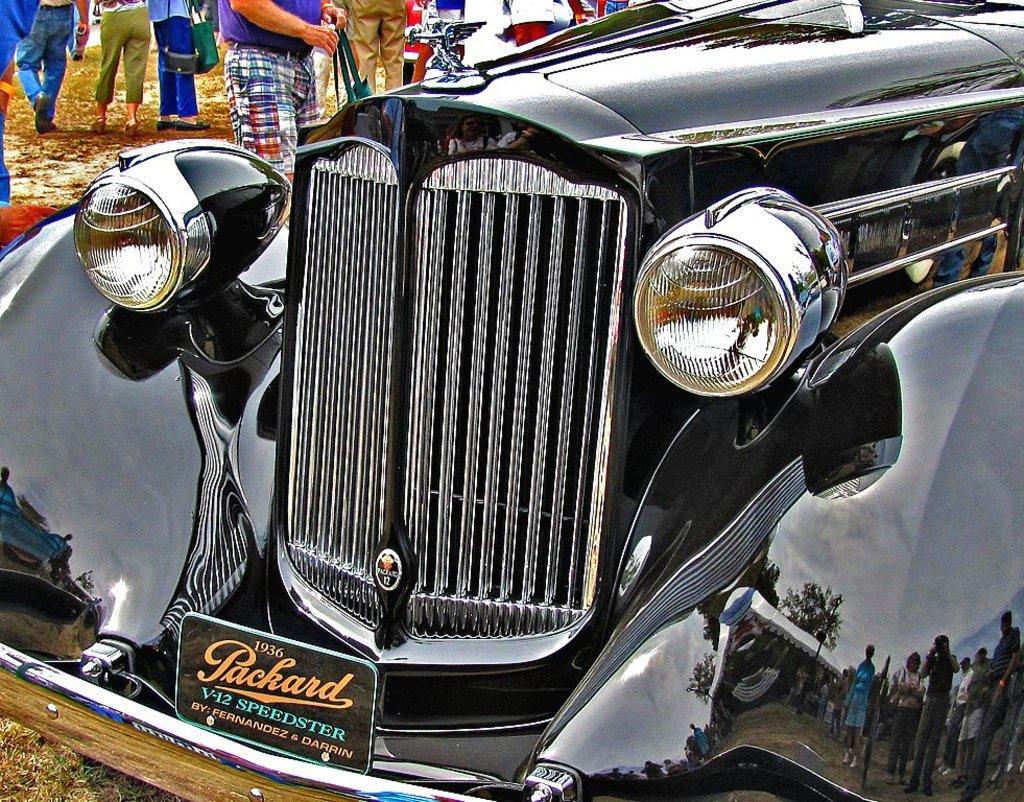Can you describe this image briefly? In this picture, we can see few people and among them a few are holding some objects, vehicle, ground with grass. 